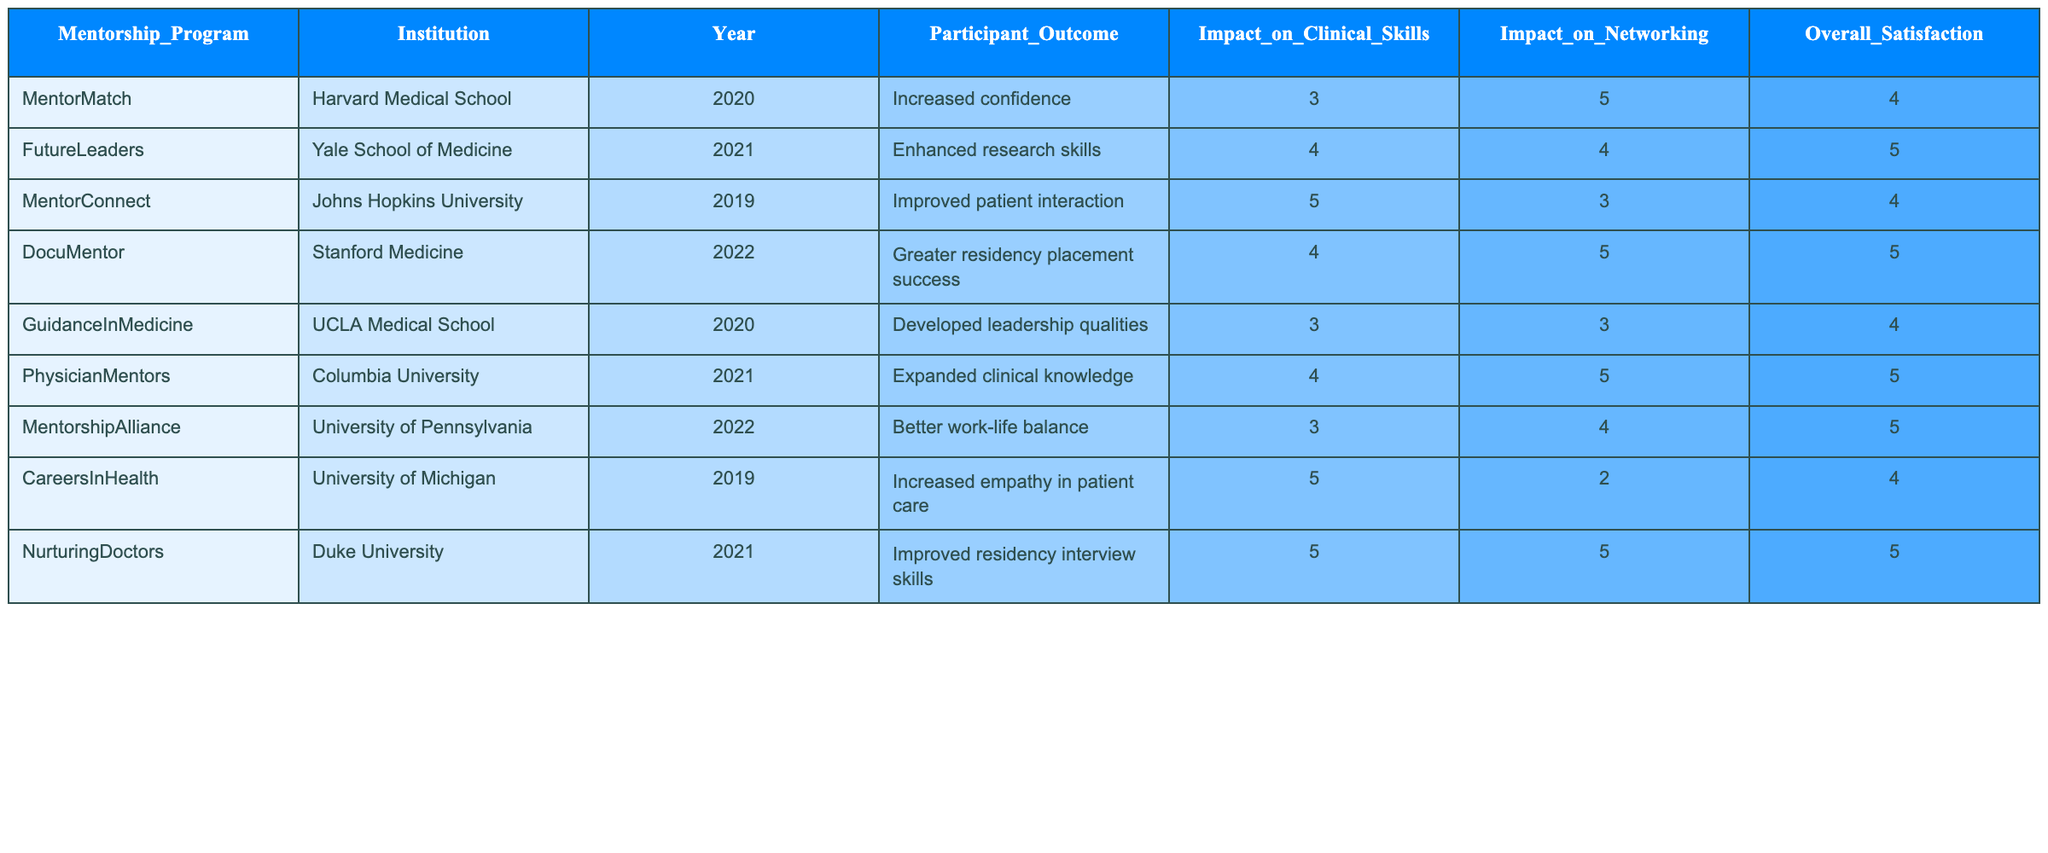What was the participant outcome of the mentorship program at Stanford Medicine in 2022? The table indicates that the participant outcome for the DocuMentor program at Stanford Medicine in 2022 was "Greater residency placement success."
Answer: Greater residency placement success Which institution had a mentorship program that improved patient interaction? The table shows that the mentorship program at Johns Hopkins University, called MentorConnect, had the outcome of "Improved patient interaction."
Answer: Johns Hopkins University What is the overall satisfaction score for the FutureLeaders mentorship program? Referring to the table, the overall satisfaction score for the FutureLeaders program at Yale School of Medicine is 5.
Answer: 5 Which mentorship program had the highest impact on clinical skills? Upon reviewing the table, the MentorConnect program at Johns Hopkins University had the highest impact on clinical skills with a score of 5.
Answer: MentorConnect How many mentorship programs reported an impact on networking with a score of 5? By examining the table, there are two programs with an impact on networking scored at 5: DocuMentor and PhysicianMentors.
Answer: 2 Is it true that the NurturingDoctors program improved leadership qualities among participants? The table shows that the participant outcome for the NurturingDoctors program was "Improved residency interview skills," not leadership qualities. Therefore, the statement is false.
Answer: No What was the average impact on clinical skills across all mentorship programs listed? To find the average, sum the impact on clinical skills scores (3 + 4 + 5 + 4 + 3 + 4 + 3 + 5 + 5 = 36) and divide by the number of programs (9), which gives an average of 4.
Answer: 4 Which program had both the highest impact on networking and the highest overall satisfaction? From the table, the DocuMentor program had the highest impact on networking (5) and also achieved an overall satisfaction score of 5.
Answer: DocuMentor What percentage of programs has an overall satisfaction score of 5? There are 3 programs (FutureLeaders, PhysicianMentors, and DocuMentor) that scored 5 for overall satisfaction out of 9 programs total. Thus, the percentage is (3/9) * 100 = 33.33%.
Answer: 33.33% Which program from Columbia University had the highest impact on networking? The table shows that the PhysicianMentors program from Columbia University had an impact on networking scored at 5, which is the highest among the listed programs.
Answer: PhysicianMentors 